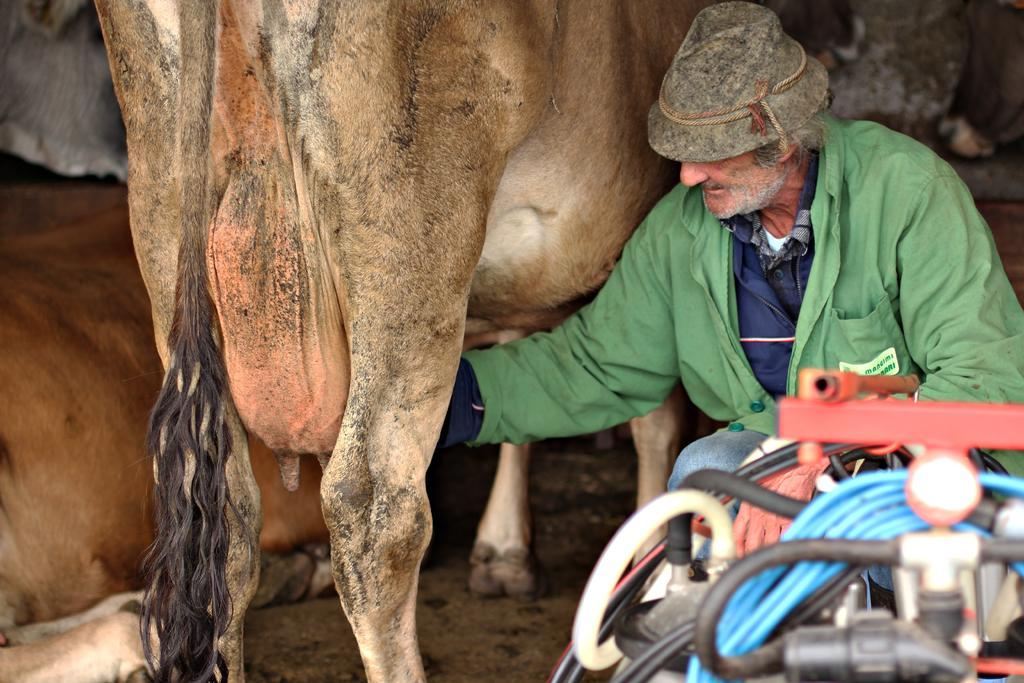What types of living beings are present in the image? There are two animals in the image. Can you describe the person in the image? There is a person wearing a green dress in the image. What is the person doing in relation to the animals? The person is crouching beside the animals. Are there any other objects or elements in the image? Yes, there are some other objects in the right bottom corner of the image. What type of sand can be seen in the image? There is no sand present in the image. Can you describe the self-portrait of the person in the image? There is no self-portrait present in the image; it features a person wearing a green dress crouching beside two animals. 